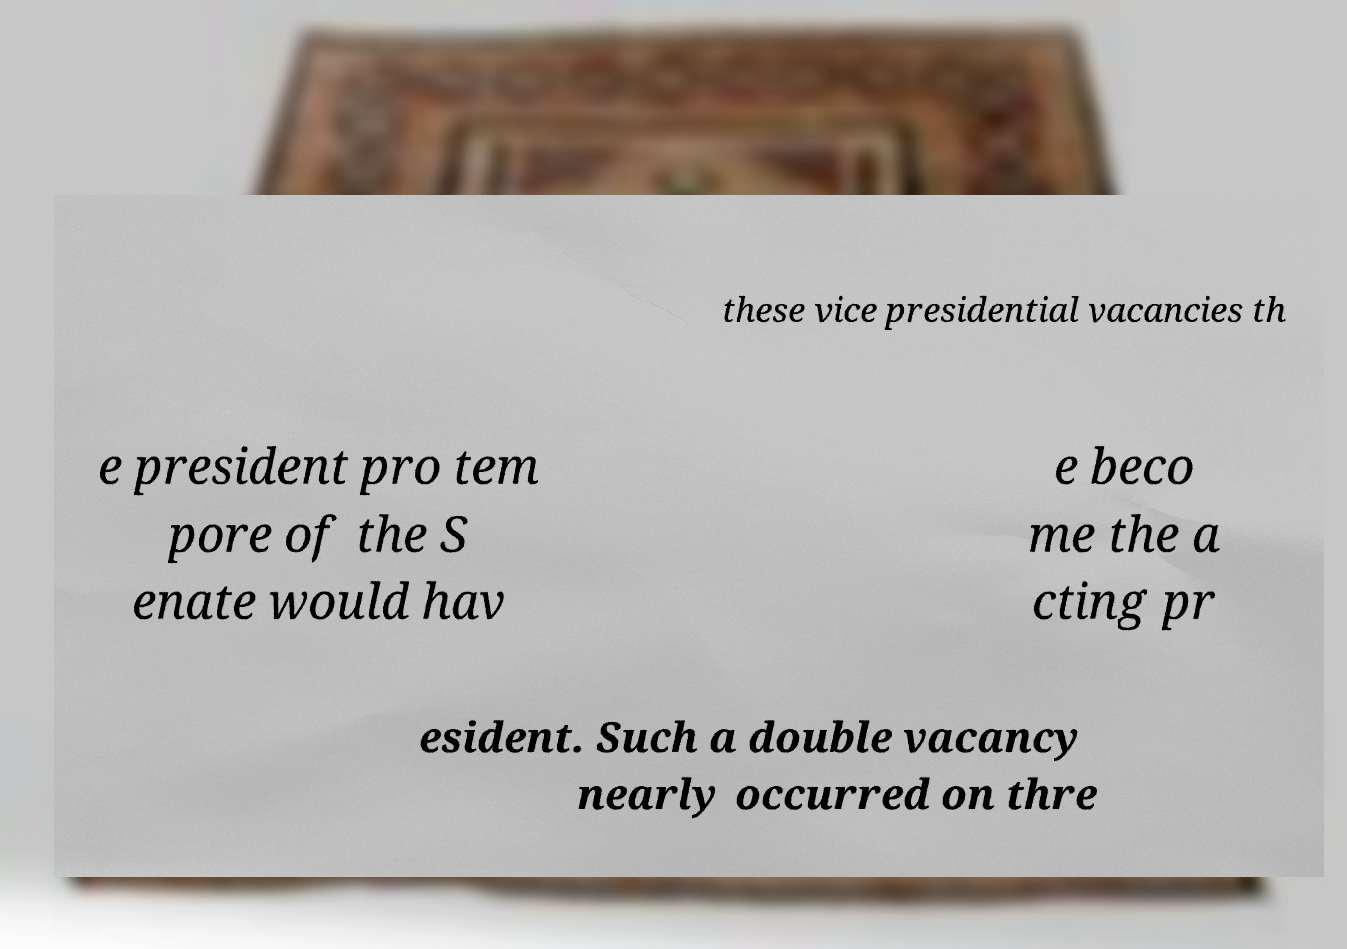Could you extract and type out the text from this image? these vice presidential vacancies th e president pro tem pore of the S enate would hav e beco me the a cting pr esident. Such a double vacancy nearly occurred on thre 